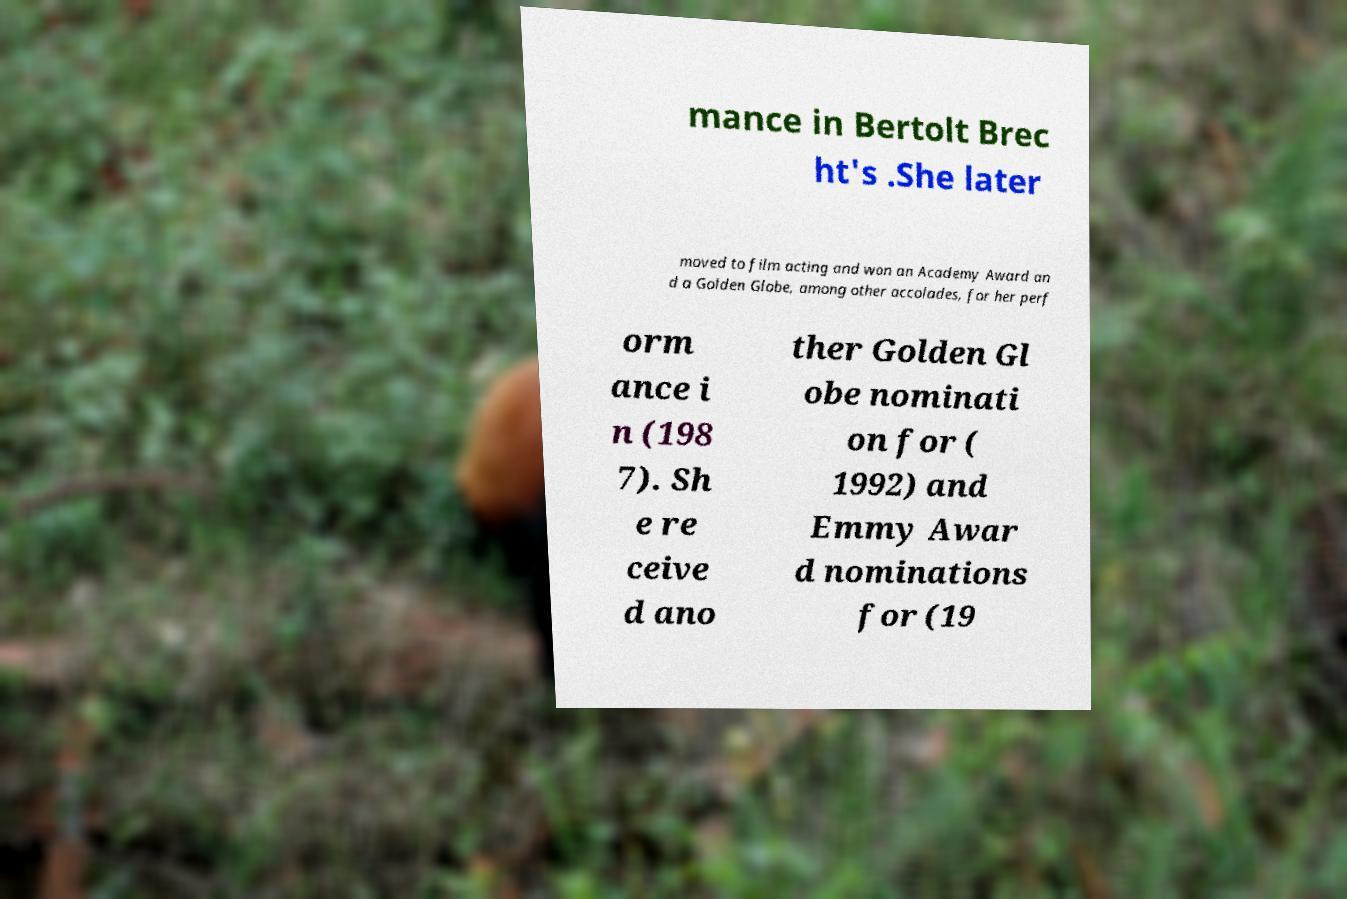Can you read and provide the text displayed in the image?This photo seems to have some interesting text. Can you extract and type it out for me? mance in Bertolt Brec ht's .She later moved to film acting and won an Academy Award an d a Golden Globe, among other accolades, for her perf orm ance i n (198 7). Sh e re ceive d ano ther Golden Gl obe nominati on for ( 1992) and Emmy Awar d nominations for (19 